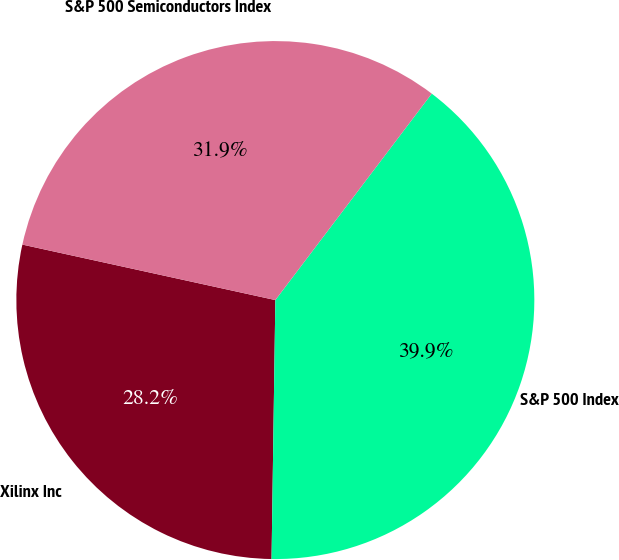Convert chart to OTSL. <chart><loc_0><loc_0><loc_500><loc_500><pie_chart><fcel>Xilinx Inc<fcel>S&P 500 Index<fcel>S&P 500 Semiconductors Index<nl><fcel>28.2%<fcel>39.91%<fcel>31.88%<nl></chart> 